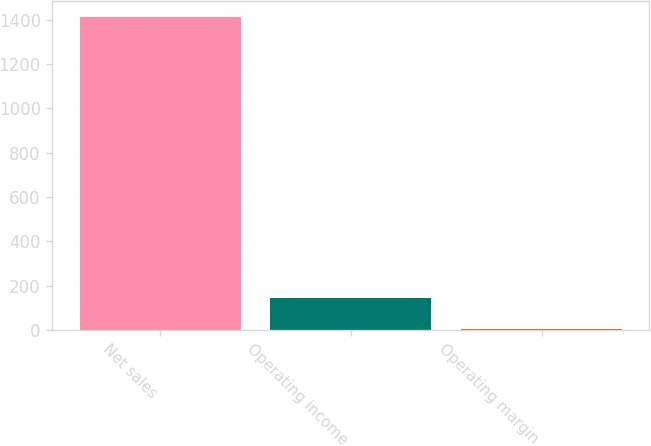Convert chart. <chart><loc_0><loc_0><loc_500><loc_500><bar_chart><fcel>Net sales<fcel>Operating income<fcel>Operating margin<nl><fcel>1415<fcel>143.66<fcel>2.4<nl></chart> 